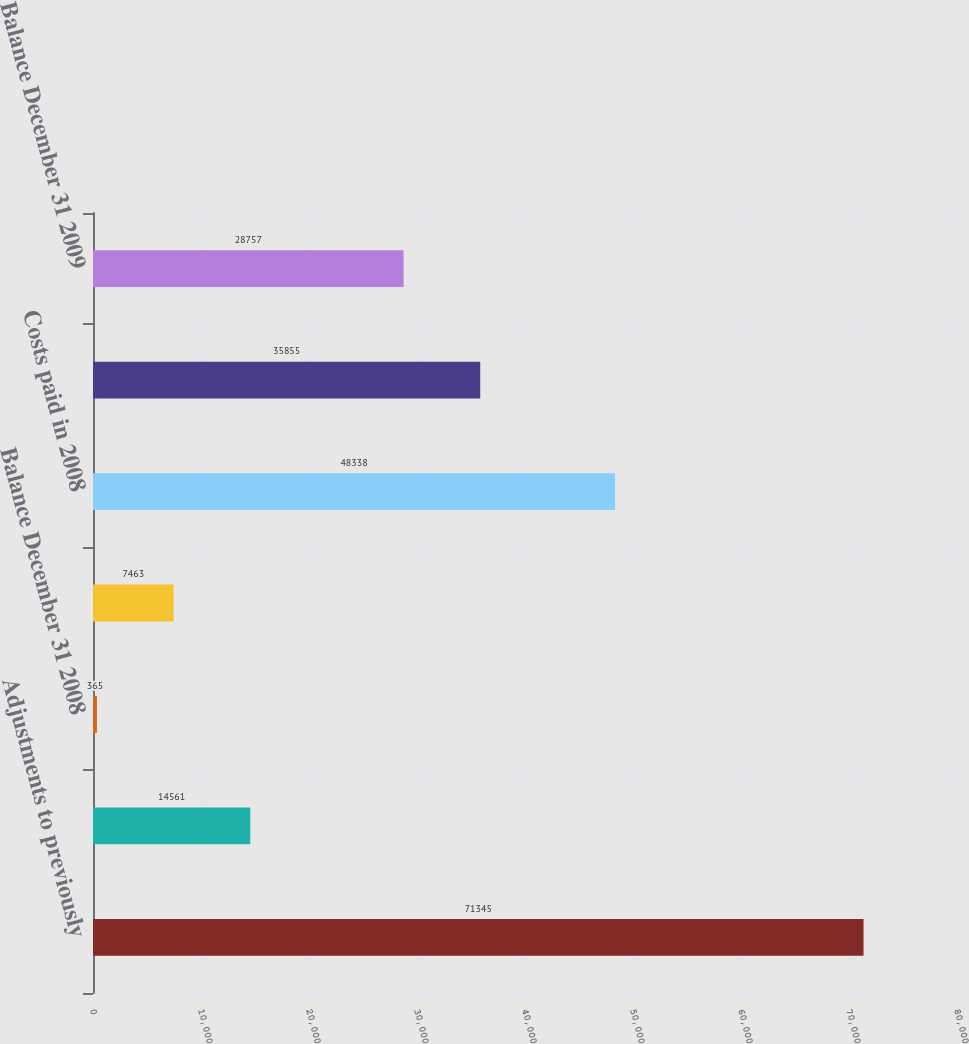Convert chart to OTSL. <chart><loc_0><loc_0><loc_500><loc_500><bar_chart><fcel>Adjustments to previously<fcel>Headcount reductions in 2008<fcel>Balance December 31 2008<fcel>Headcount reductions in 2009<fcel>Costs paid in 2008<fcel>Costs paid in 2009<fcel>Balance December 31 2009<nl><fcel>71345<fcel>14561<fcel>365<fcel>7463<fcel>48338<fcel>35855<fcel>28757<nl></chart> 